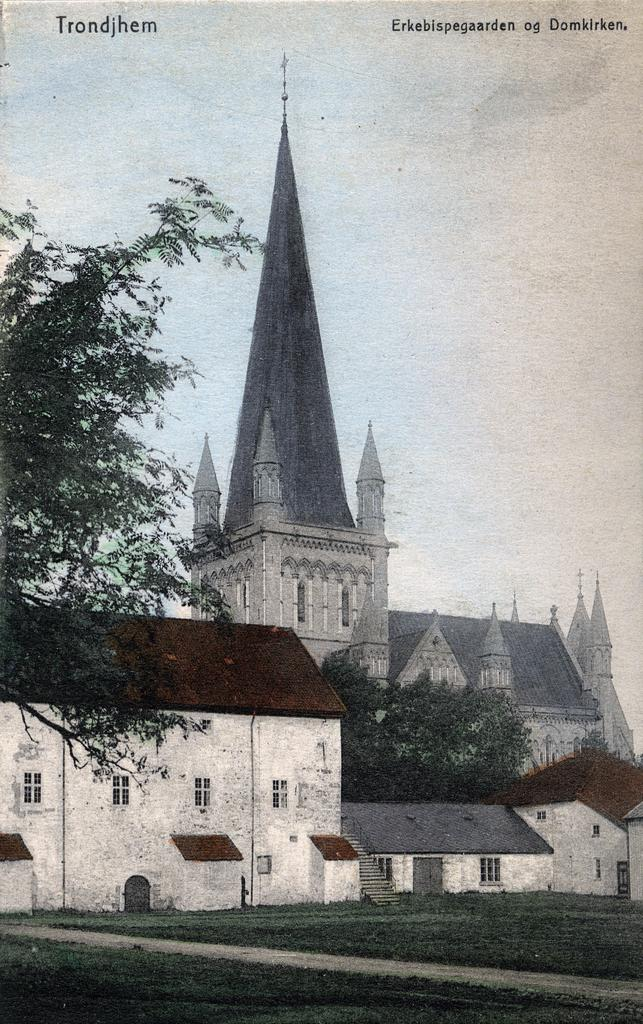What is the main subject of the image? The main subject of the image is a picture. What elements can be seen within the picture? The picture contains buildings, stairs, trees, ground, and sky. How many years are depicted in the image? There are no years visible in the image; it contains a picture with various elements, including buildings, stairs, trees, ground, and sky. What type of lumber is used to construct the buildings in the image? There is no information about the type of lumber used to construct the buildings in the image. 